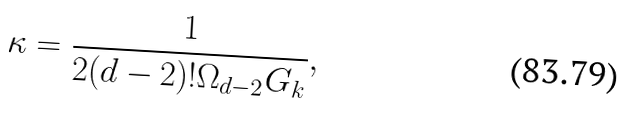Convert formula to latex. <formula><loc_0><loc_0><loc_500><loc_500>\ \kappa = \frac { 1 } { 2 ( d - 2 ) ! \Omega _ { d - 2 } G _ { k } } ,</formula> 